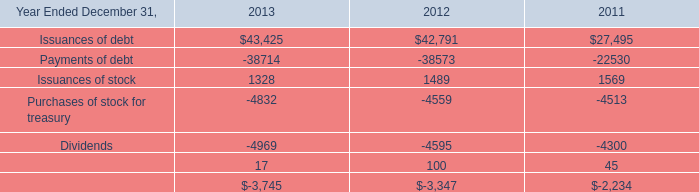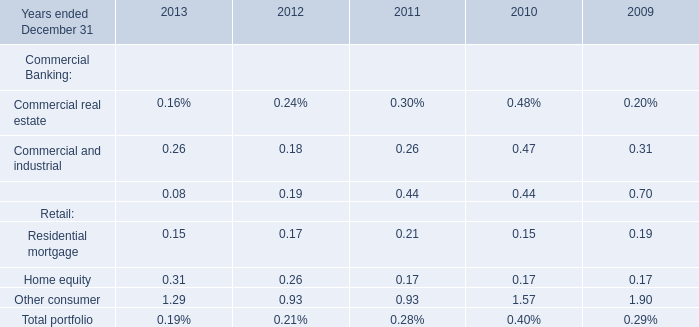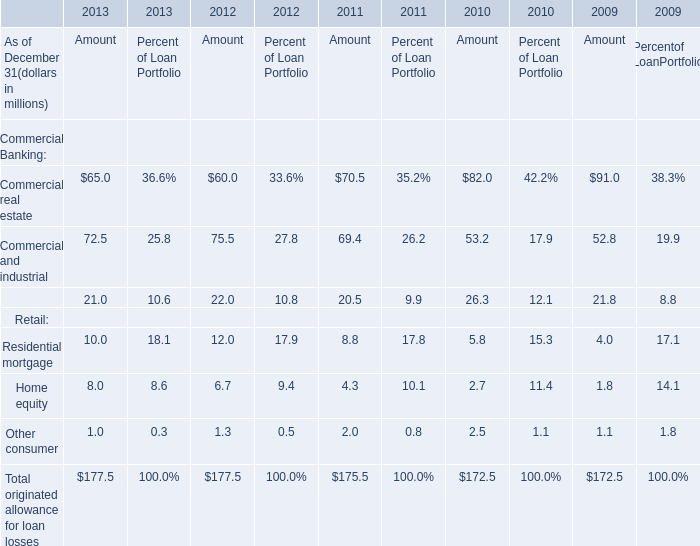What's the 20 % of total elements for Amout in 2011? (in million) 
Computations: (175.5 * 0.2)
Answer: 35.1. 